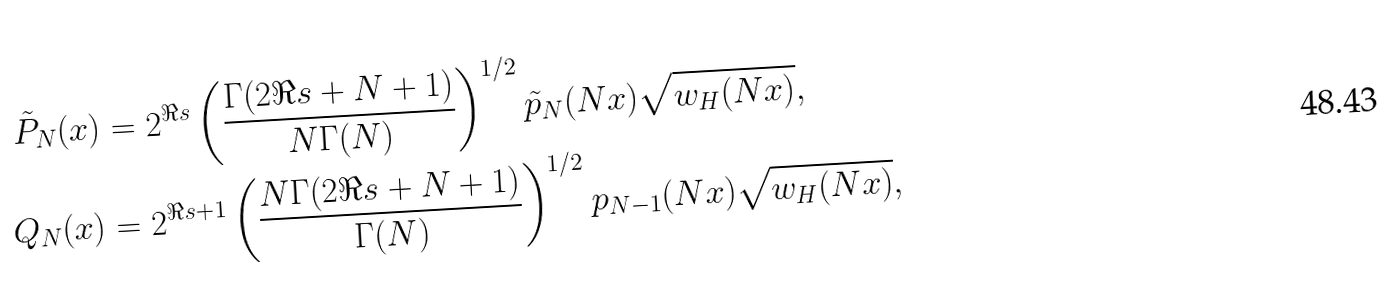Convert formula to latex. <formula><loc_0><loc_0><loc_500><loc_500>\tilde { P } _ { N } ( x ) & = 2 ^ { \Re { s } } \left ( \frac { \Gamma ( 2 \Re { s } + N + 1 ) } { N \Gamma ( N ) } \right ) ^ { 1 / 2 } \tilde { p } _ { N } ( N x ) \sqrt { w _ { H } ( N x ) } , \\ Q _ { N } ( x ) & = 2 ^ { \Re { s } + 1 } \left ( \frac { N \Gamma ( 2 \Re { s } + N + 1 ) } { \Gamma ( N ) } \right ) ^ { 1 / 2 } p _ { N - 1 } ( N x ) \sqrt { w _ { H } ( N x ) } ,</formula> 